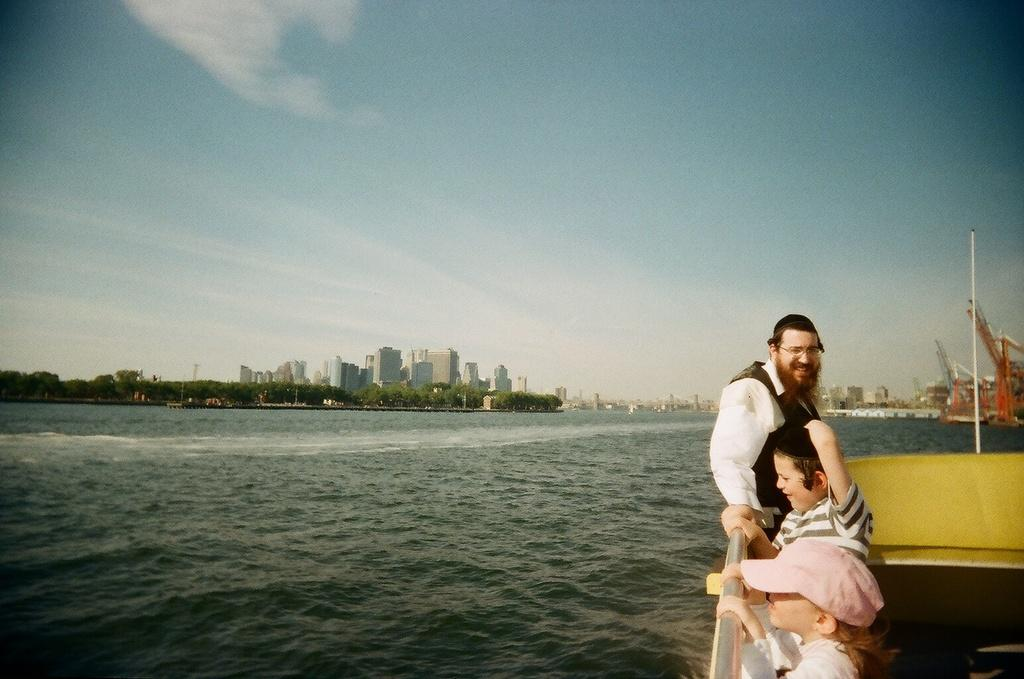How many people are on the boat in the image? There are three persons standing on a boat in the image. What is the boat's location in relation to the water? The boat is on the water. What other structures can be seen in the image? There are buildings visible in the image. What type of vegetation is present in the image? There are trees in the image. What can be seen in the background of the image? The sky is visible in the background. What type of fowl can be seen swimming near the boat in the image? There are no fowl visible in the image; it only shows three persons on a boat, buildings, trees, and the sky. 